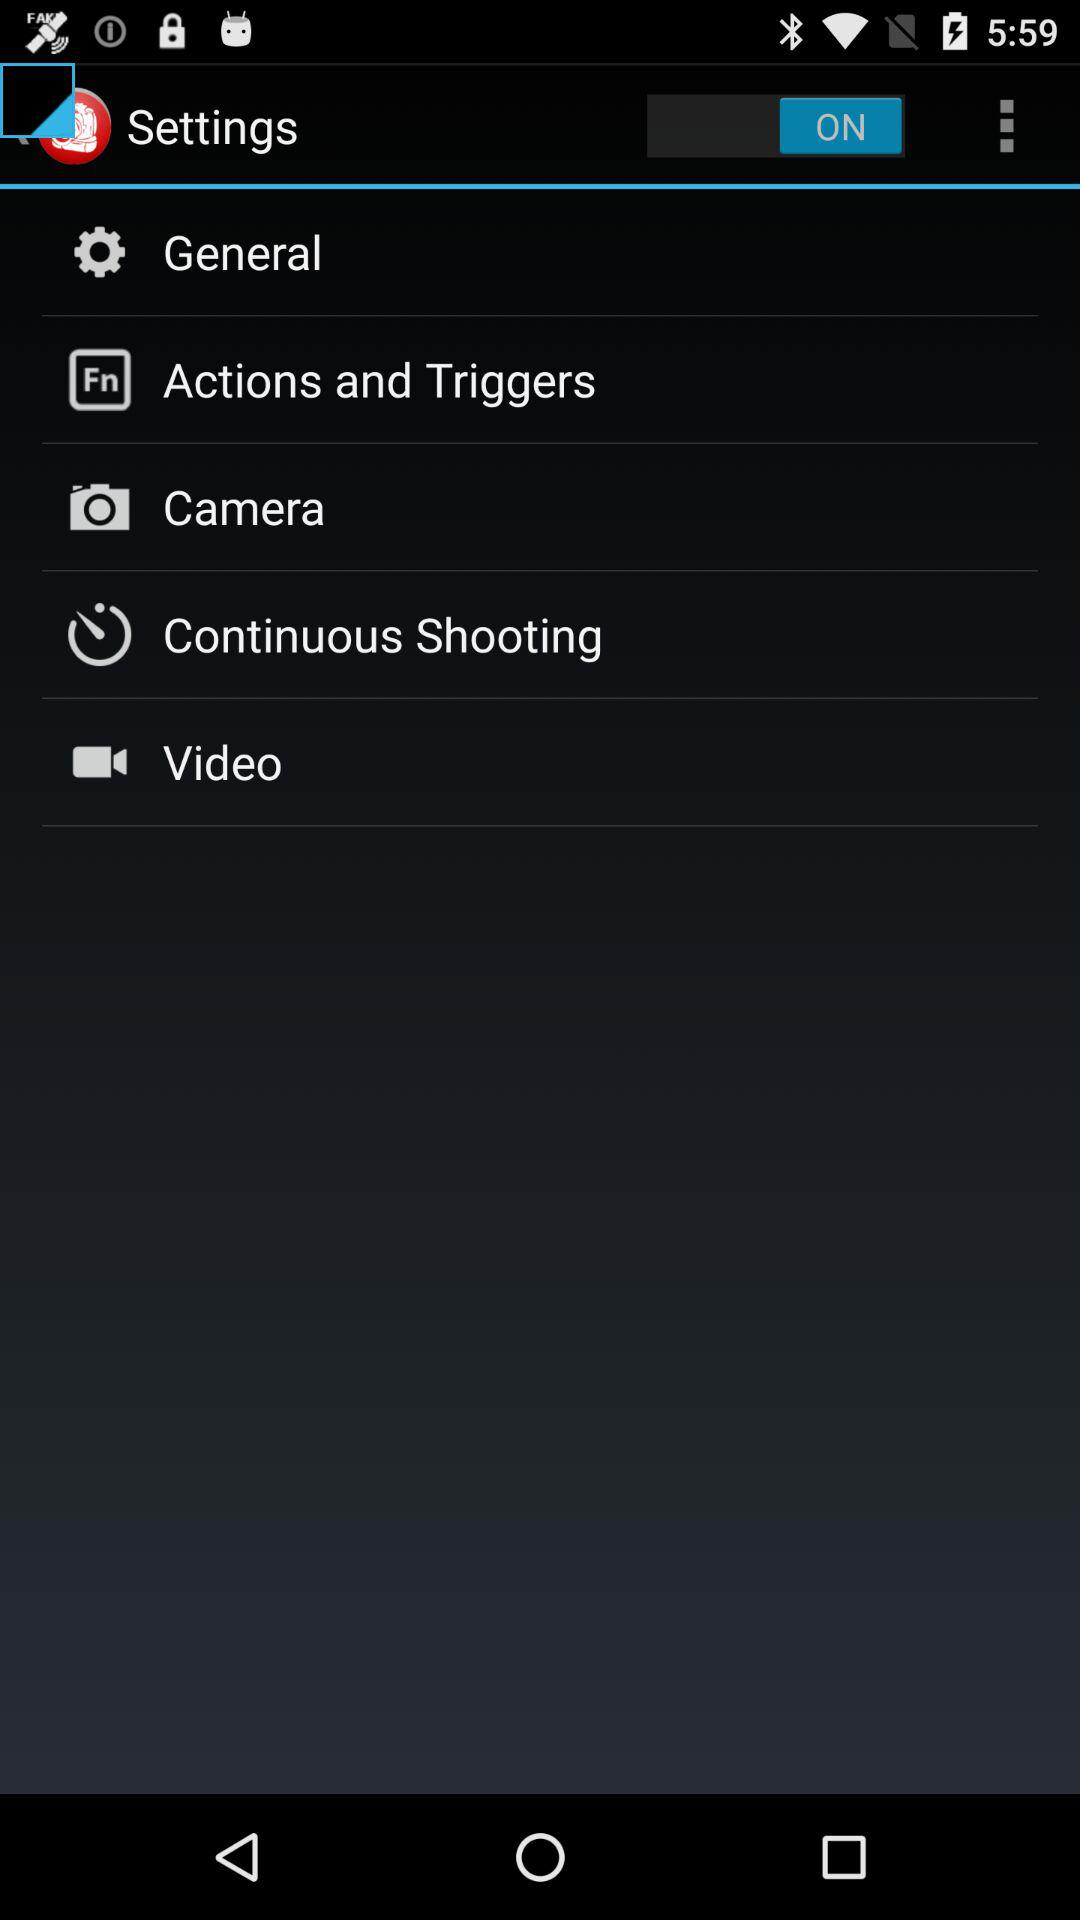What is the status of "Settings"? The status is "on". 